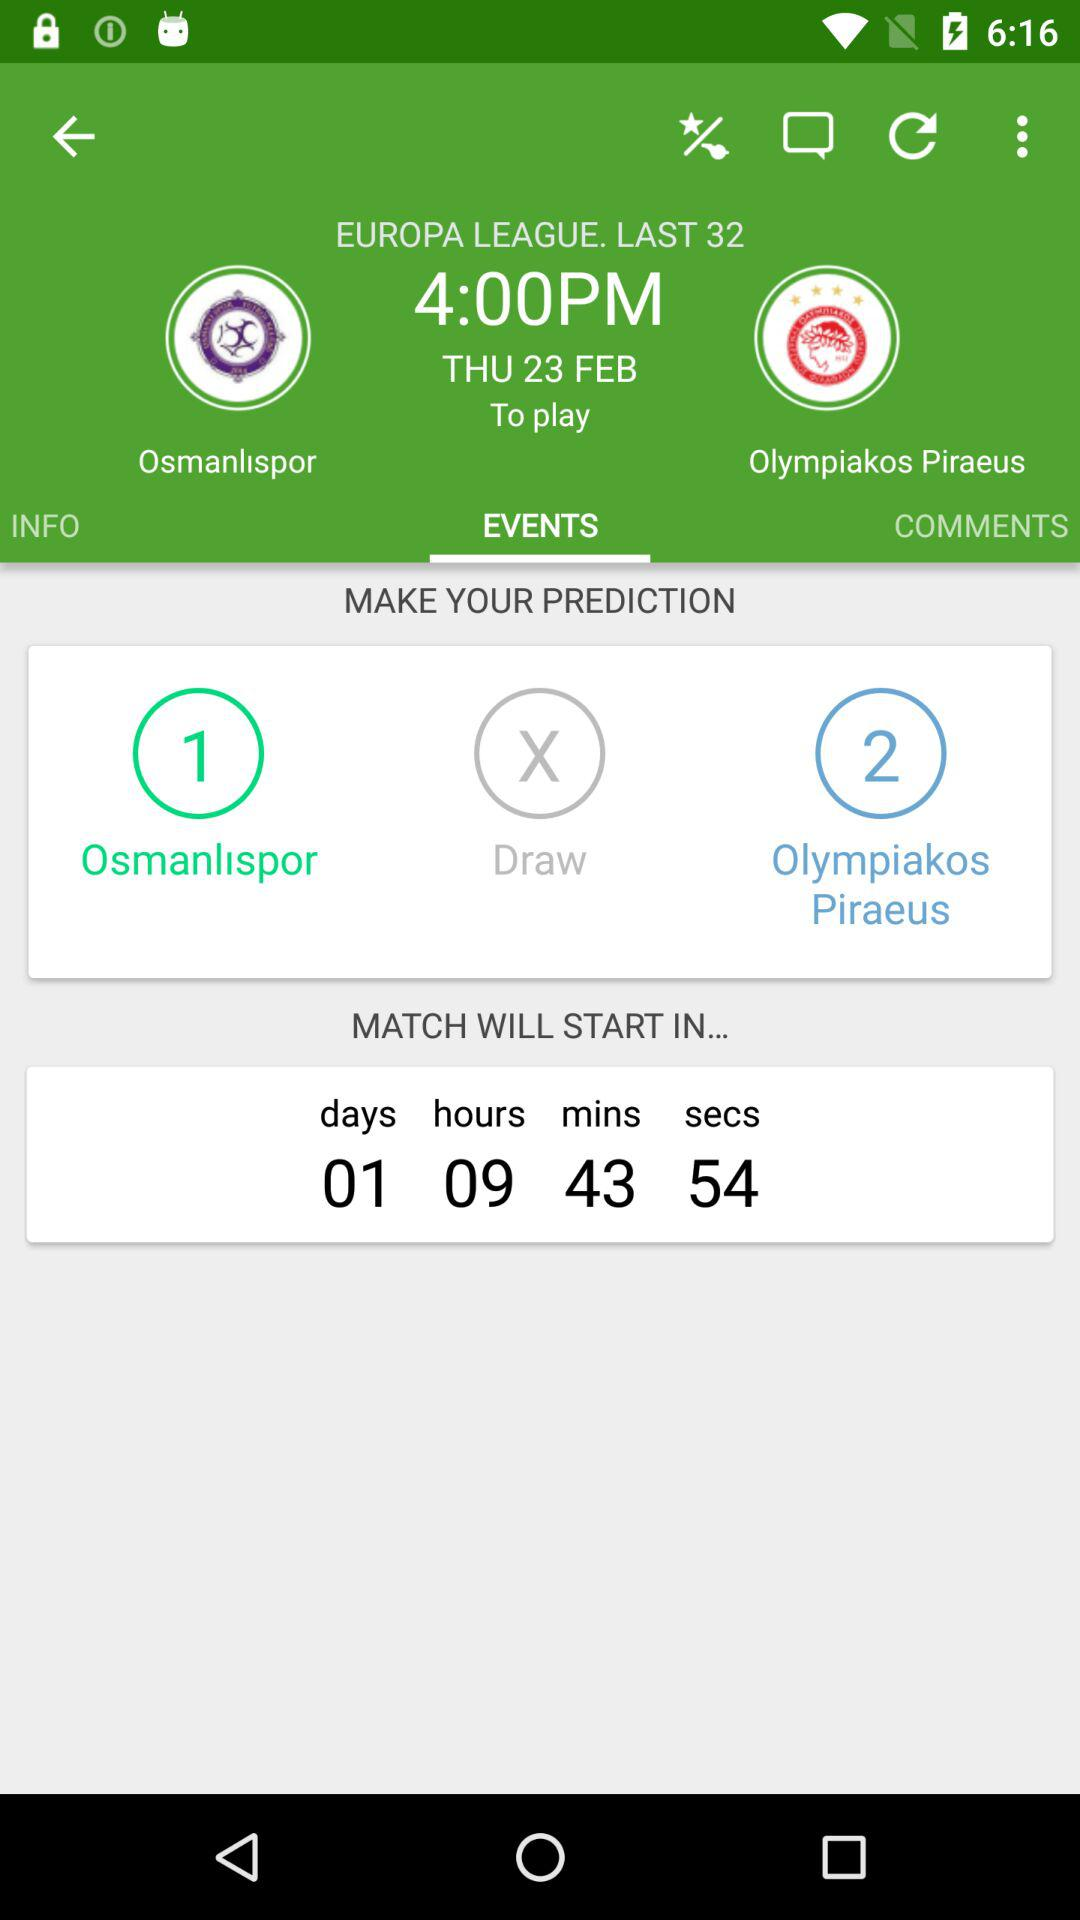What are the names of the football clubs? The names of the football clubs are "Osmanlispor" and "Olympiakos Piraeus". 